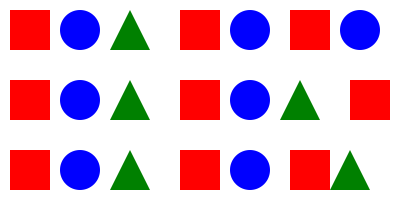In this DNA sequence representation, each shape corresponds to a specific nucleotide base. If red squares represent Adenine (A), blue circles represent Cytosine (C), and green triangles represent Guanine (G), what is the missing nucleotide base, and how many times does it appear in the complete sequence? To solve this problem, we need to follow these steps:

1. Identify the missing nucleotide base:
   - We see red squares (A), blue circles (C), and green triangles (G)
   - The only missing nucleotide base is Thymine (T)

2. Count the total number of shapes:
   - Row 1: 7 shapes
   - Row 2: 7 shapes
   - Row 3: 7 shapes
   - Total: 21 shapes

3. Count the number of each known shape:
   - Red squares (A): 7
   - Blue circles (C): 6
   - Green triangles (G): 4

4. Calculate the number of missing shapes:
   - Total shapes - (A + C + G) = Missing shapes (T)
   - 21 - (7 + 6 + 4) = 4

Therefore, the missing nucleotide base is Thymine (T), and it appears 4 times in the complete sequence.
Answer: Thymine (T), 4 times 